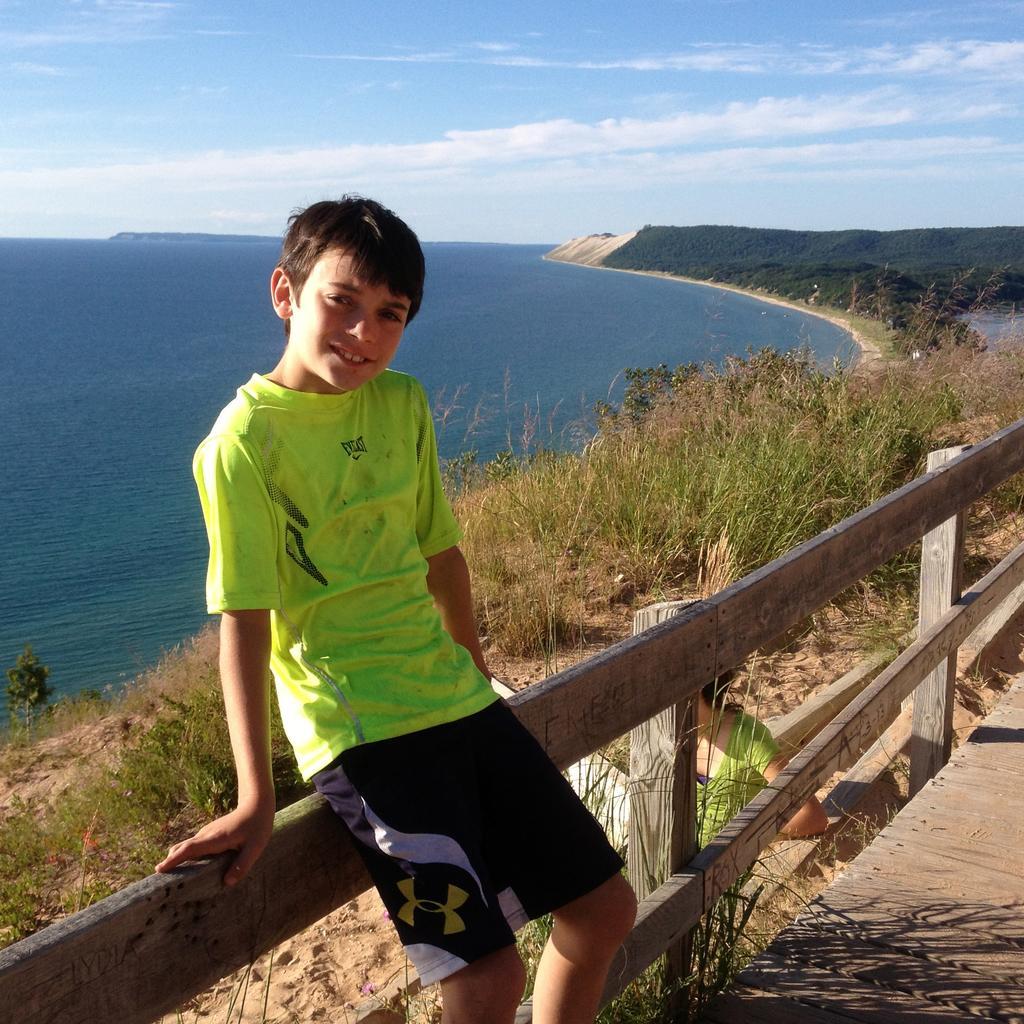Can you describe this image briefly? In this image we can a boy is standing, he is wearing green color t-shirt with shorts. Behind him one wooden fencing is there. Behind the fencing grass and sea is present. The sky is clear with some clouds. 